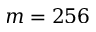Convert formula to latex. <formula><loc_0><loc_0><loc_500><loc_500>m = 2 5 6</formula> 